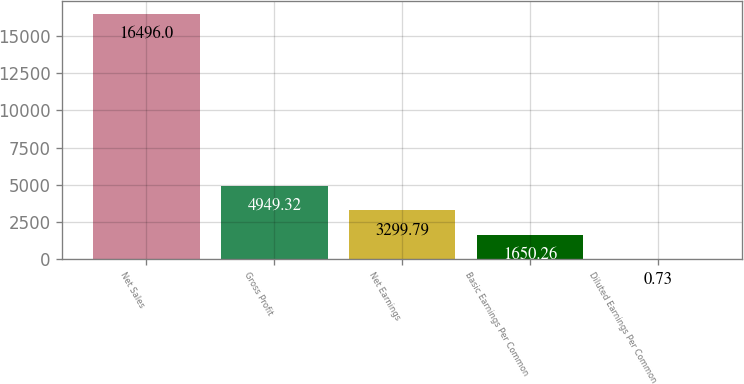<chart> <loc_0><loc_0><loc_500><loc_500><bar_chart><fcel>Net Sales<fcel>Gross Profit<fcel>Net Earnings<fcel>Basic Earnings Per Common<fcel>Diluted Earnings Per Common<nl><fcel>16496<fcel>4949.32<fcel>3299.79<fcel>1650.26<fcel>0.73<nl></chart> 